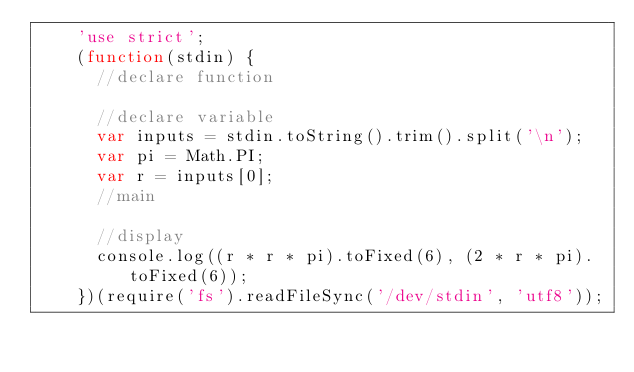Convert code to text. <code><loc_0><loc_0><loc_500><loc_500><_JavaScript_>    'use strict';
    (function(stdin) {
      //declare function

      //declare variable
      var inputs = stdin.toString().trim().split('\n');
      var pi = Math.PI;
      var r = inputs[0];
      //main

      //display
      console.log((r * r * pi).toFixed(6), (2 * r * pi).toFixed(6));
    })(require('fs').readFileSync('/dev/stdin', 'utf8'));</code> 